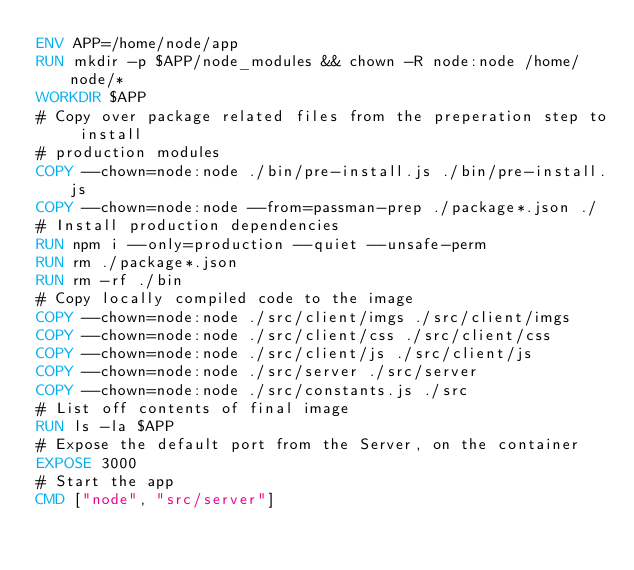<code> <loc_0><loc_0><loc_500><loc_500><_Dockerfile_>ENV APP=/home/node/app
RUN mkdir -p $APP/node_modules && chown -R node:node /home/node/*
WORKDIR $APP
# Copy over package related files from the preperation step to install
# production modules
COPY --chown=node:node ./bin/pre-install.js ./bin/pre-install.js
COPY --chown=node:node --from=passman-prep ./package*.json ./
# Install production dependencies
RUN npm i --only=production --quiet --unsafe-perm
RUN rm ./package*.json
RUN rm -rf ./bin
# Copy locally compiled code to the image
COPY --chown=node:node ./src/client/imgs ./src/client/imgs
COPY --chown=node:node ./src/client/css ./src/client/css
COPY --chown=node:node ./src/client/js ./src/client/js
COPY --chown=node:node ./src/server ./src/server
COPY --chown=node:node ./src/constants.js ./src
# List off contents of final image
RUN ls -la $APP
# Expose the default port from the Server, on the container
EXPOSE 3000
# Start the app
CMD ["node", "src/server"]</code> 